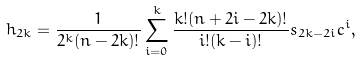Convert formula to latex. <formula><loc_0><loc_0><loc_500><loc_500>h _ { 2 k } = \frac { 1 } { 2 ^ { k } ( n - 2 k ) ! } \sum _ { i = 0 } ^ { k } \frac { k ! ( n + 2 i - 2 k ) ! } { i ! ( k - i ) ! } s _ { 2 k - 2 i } c ^ { i } ,</formula> 